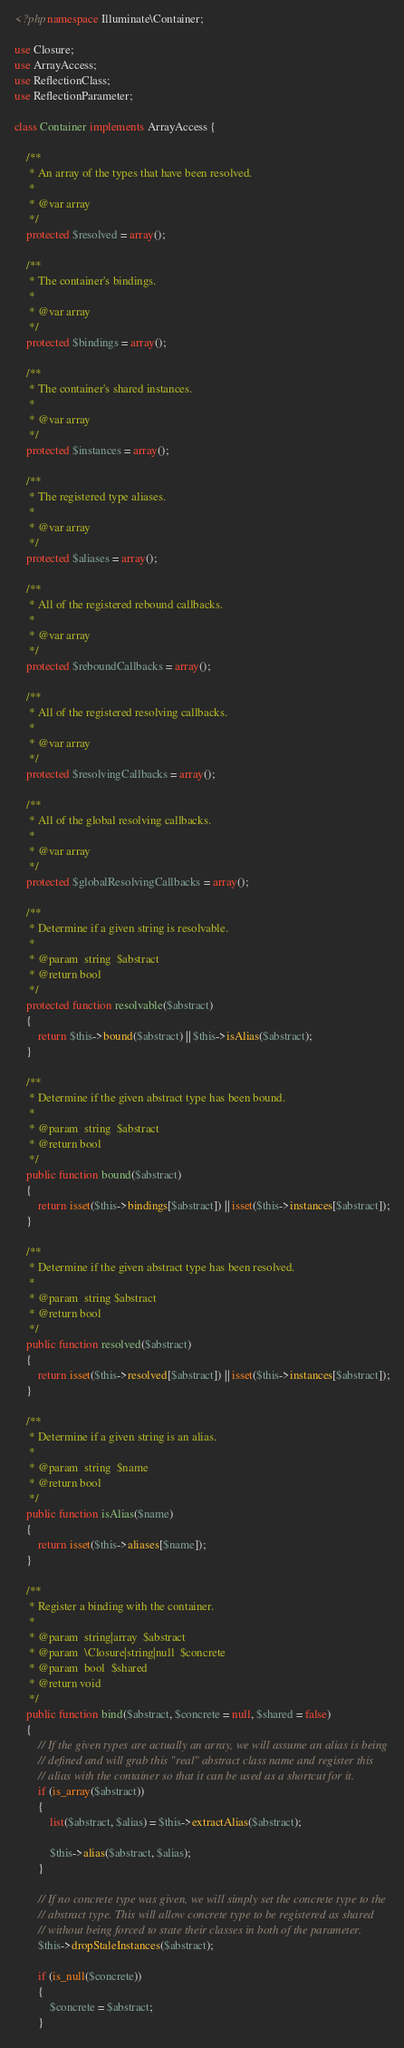<code> <loc_0><loc_0><loc_500><loc_500><_PHP_><?php namespace Illuminate\Container;

use Closure;
use ArrayAccess;
use ReflectionClass;
use ReflectionParameter;

class Container implements ArrayAccess {

	/**
	 * An array of the types that have been resolved.
	 *
	 * @var array
	 */
	protected $resolved = array();

	/**
	 * The container's bindings.
	 *
	 * @var array
	 */
	protected $bindings = array();

	/**
	 * The container's shared instances.
	 *
	 * @var array
	 */
	protected $instances = array();

	/**
	 * The registered type aliases.
	 *
	 * @var array
	 */
	protected $aliases = array();

	/**
	 * All of the registered rebound callbacks.
	 *
	 * @var array
	 */
	protected $reboundCallbacks = array();

	/**
	 * All of the registered resolving callbacks.
	 *
	 * @var array
	 */
	protected $resolvingCallbacks = array();

	/**
	 * All of the global resolving callbacks.
	 *
	 * @var array
	 */
	protected $globalResolvingCallbacks = array();

	/**
	 * Determine if a given string is resolvable.
	 *
	 * @param  string  $abstract
	 * @return bool
	 */
	protected function resolvable($abstract)
	{
		return $this->bound($abstract) || $this->isAlias($abstract);
	}

	/**
	 * Determine if the given abstract type has been bound.
	 *
	 * @param  string  $abstract
	 * @return bool
	 */
	public function bound($abstract)
	{
		return isset($this->bindings[$abstract]) || isset($this->instances[$abstract]);
	}

	/**
	 * Determine if the given abstract type has been resolved.
	 *
	 * @param  string $abstract
	 * @return bool
	 */
	public function resolved($abstract)
	{
		return isset($this->resolved[$abstract]) || isset($this->instances[$abstract]);
	}

	/**
	 * Determine if a given string is an alias.
	 *
	 * @param  string  $name
	 * @return bool
	 */
	public function isAlias($name)
	{
		return isset($this->aliases[$name]);
	}

	/**
	 * Register a binding with the container.
	 *
	 * @param  string|array  $abstract
	 * @param  \Closure|string|null  $concrete
	 * @param  bool  $shared
	 * @return void
	 */
	public function bind($abstract, $concrete = null, $shared = false)
	{
		// If the given types are actually an array, we will assume an alias is being
		// defined and will grab this "real" abstract class name and register this
		// alias with the container so that it can be used as a shortcut for it.
		if (is_array($abstract))
		{
			list($abstract, $alias) = $this->extractAlias($abstract);

			$this->alias($abstract, $alias);
		}

		// If no concrete type was given, we will simply set the concrete type to the
		// abstract type. This will allow concrete type to be registered as shared
		// without being forced to state their classes in both of the parameter.
		$this->dropStaleInstances($abstract);

		if (is_null($concrete))
		{
			$concrete = $abstract;
		}
</code> 